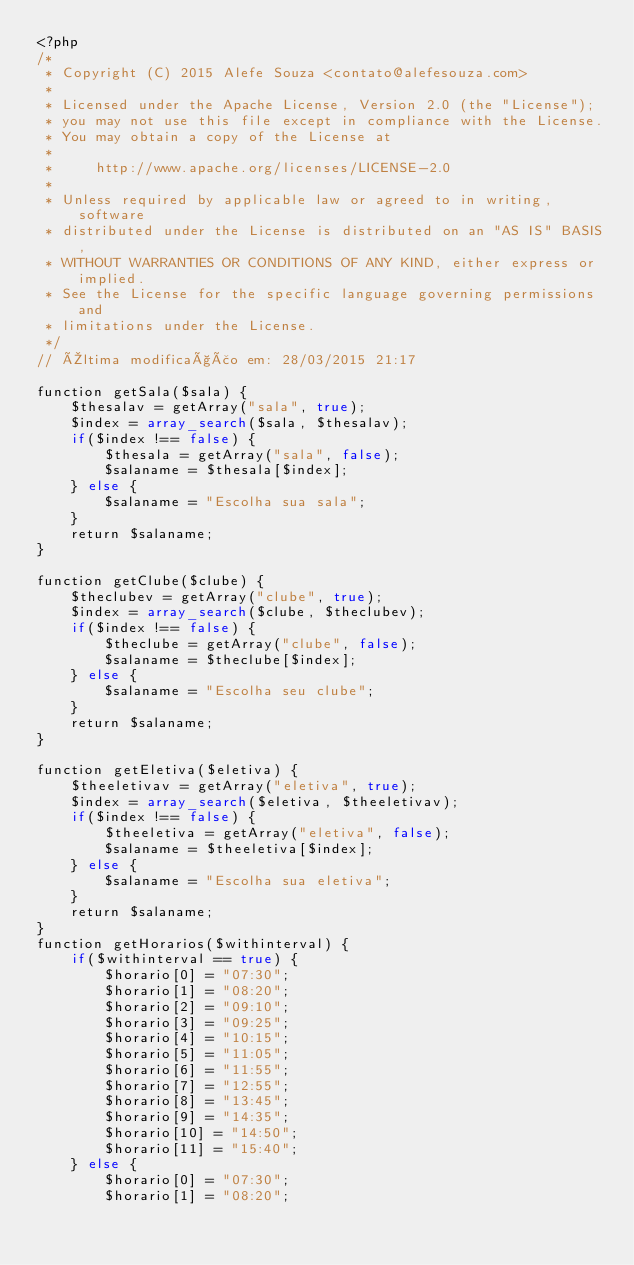Convert code to text. <code><loc_0><loc_0><loc_500><loc_500><_PHP_><?php
/*
 * Copyright (C) 2015 Alefe Souza <contato@alefesouza.com>
 *
 * Licensed under the Apache License, Version 2.0 (the "License");
 * you may not use this file except in compliance with the License.
 * You may obtain a copy of the License at
 *
 *     http://www.apache.org/licenses/LICENSE-2.0
 *
 * Unless required by applicable law or agreed to in writing, software
 * distributed under the License is distributed on an "AS IS" BASIS,
 * WITHOUT WARRANTIES OR CONDITIONS OF ANY KIND, either express or implied.
 * See the License for the specific language governing permissions and
 * limitations under the License.
 */
// Última modificação em: 28/03/2015 21:17

function getSala($sala) {
	$thesalav = getArray("sala", true);
	$index = array_search($sala, $thesalav);
	if($index !== false) {
		$thesala = getArray("sala", false);
		$salaname = $thesala[$index];
	} else {
		$salaname = "Escolha sua sala";
	}
	return $salaname;
}

function getClube($clube) {
	$theclubev = getArray("clube", true);
	$index = array_search($clube, $theclubev);
	if($index !== false) {
		$theclube = getArray("clube", false);
		$salaname = $theclube[$index];
	} else {
		$salaname = "Escolha seu clube";
	}
	return $salaname;
}

function getEletiva($eletiva) {
	$theeletivav = getArray("eletiva", true);
	$index = array_search($eletiva, $theeletivav);
	if($index !== false) {
		$theeletiva = getArray("eletiva", false);
		$salaname = $theeletiva[$index];
	} else {
		$salaname = "Escolha sua eletiva";
	}
	return $salaname;
}
function getHorarios($withinterval) {
	if($withinterval == true) {
		$horario[0] = "07:30";
		$horario[1] = "08:20";
		$horario[2] = "09:10";
		$horario[3] = "09:25";
		$horario[4] = "10:15";
		$horario[5] = "11:05";
		$horario[6] = "11:55";
		$horario[7] = "12:55";
		$horario[8] = "13:45";
		$horario[9] = "14:35";
		$horario[10] = "14:50";
		$horario[11] = "15:40";
	} else {
		$horario[0] = "07:30";
		$horario[1] = "08:20";</code> 